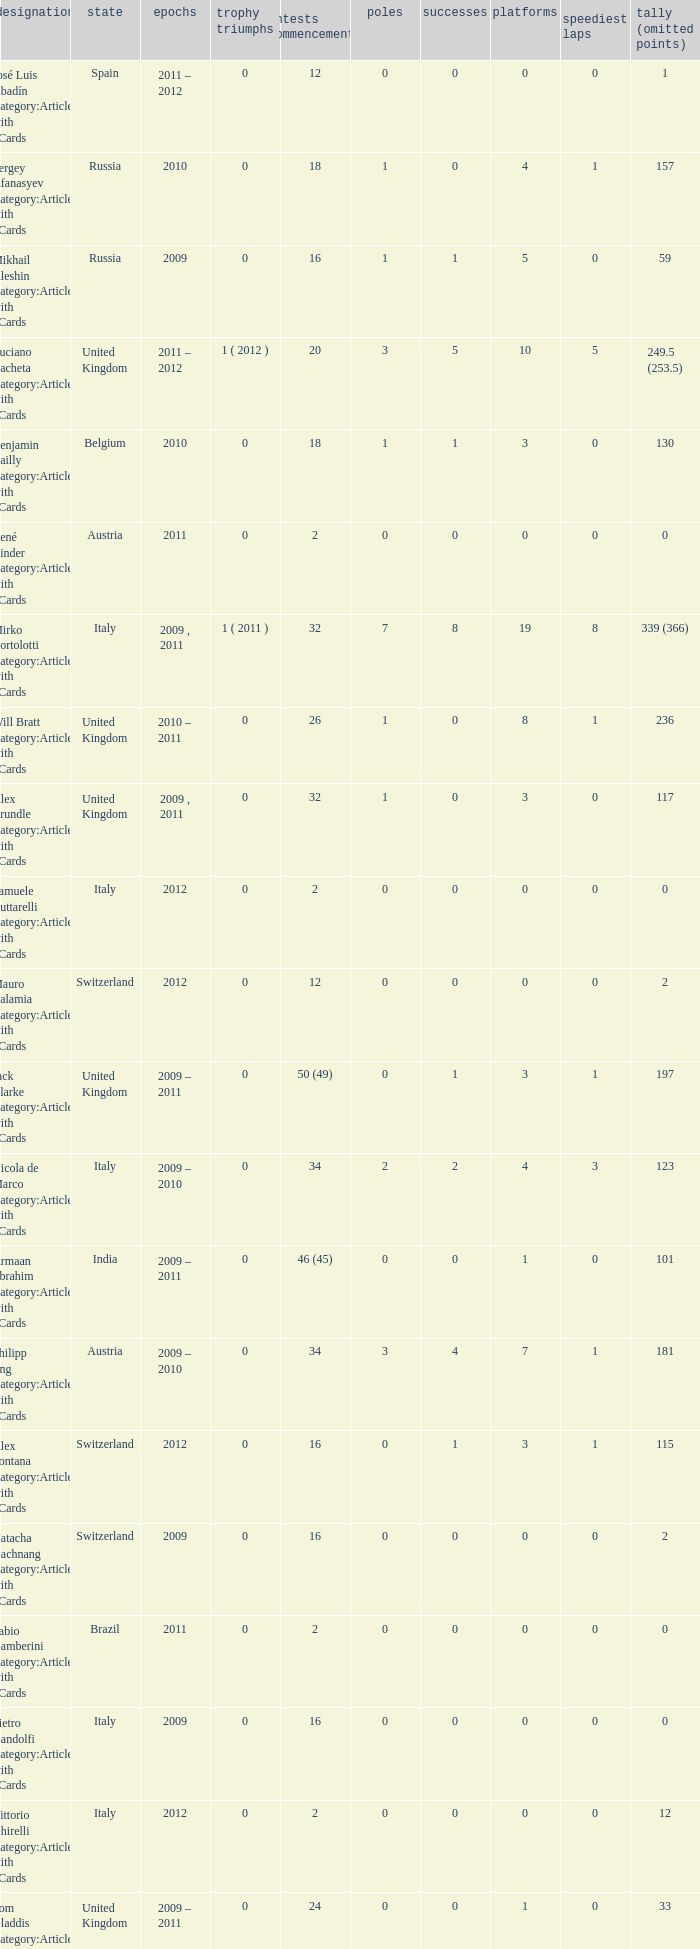When did they win 7 races? 2009.0. 